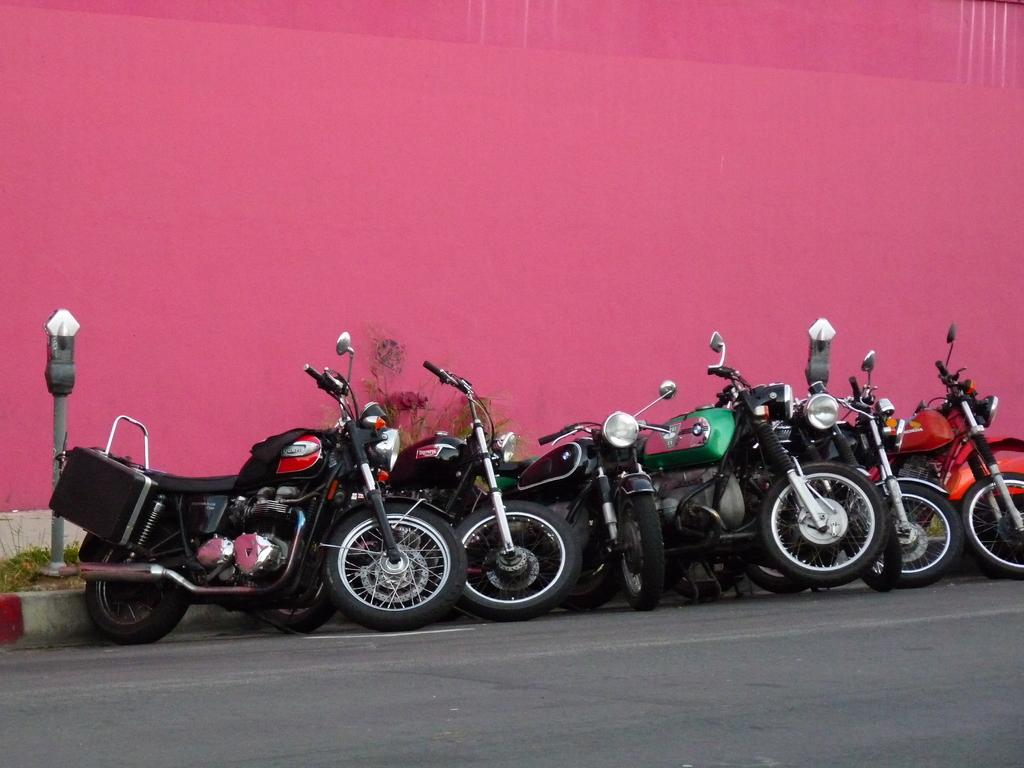What can be seen parked on the road in the image? There are bikes parked on the road in the image. What color is the wall visible in the image? There is a pink color wall visible in the image. Where is the sister standing in the image? There is no sister present in the image. What type of pickle is being used to decorate the wall in the image? There is no pickle present in the image, and the wall is not being decorated. 